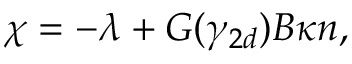Convert formula to latex. <formula><loc_0><loc_0><loc_500><loc_500>\begin{array} { r } { \chi = - \lambda + G ( \gamma _ { 2 d } ) B \kappa n , } \end{array}</formula> 